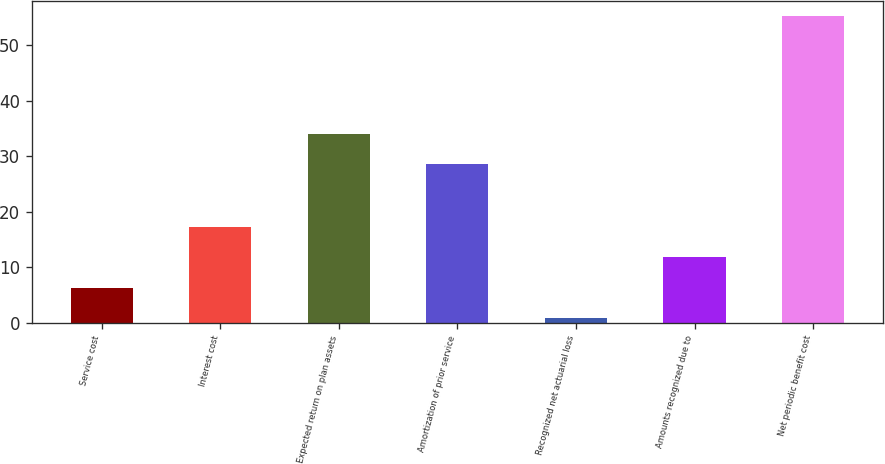Convert chart to OTSL. <chart><loc_0><loc_0><loc_500><loc_500><bar_chart><fcel>Service cost<fcel>Interest cost<fcel>Expected return on plan assets<fcel>Amortization of prior service<fcel>Recognized net actuarial loss<fcel>Amounts recognized due to<fcel>Net periodic benefit cost<nl><fcel>6.33<fcel>17.19<fcel>34.03<fcel>28.6<fcel>0.9<fcel>11.76<fcel>55.2<nl></chart> 